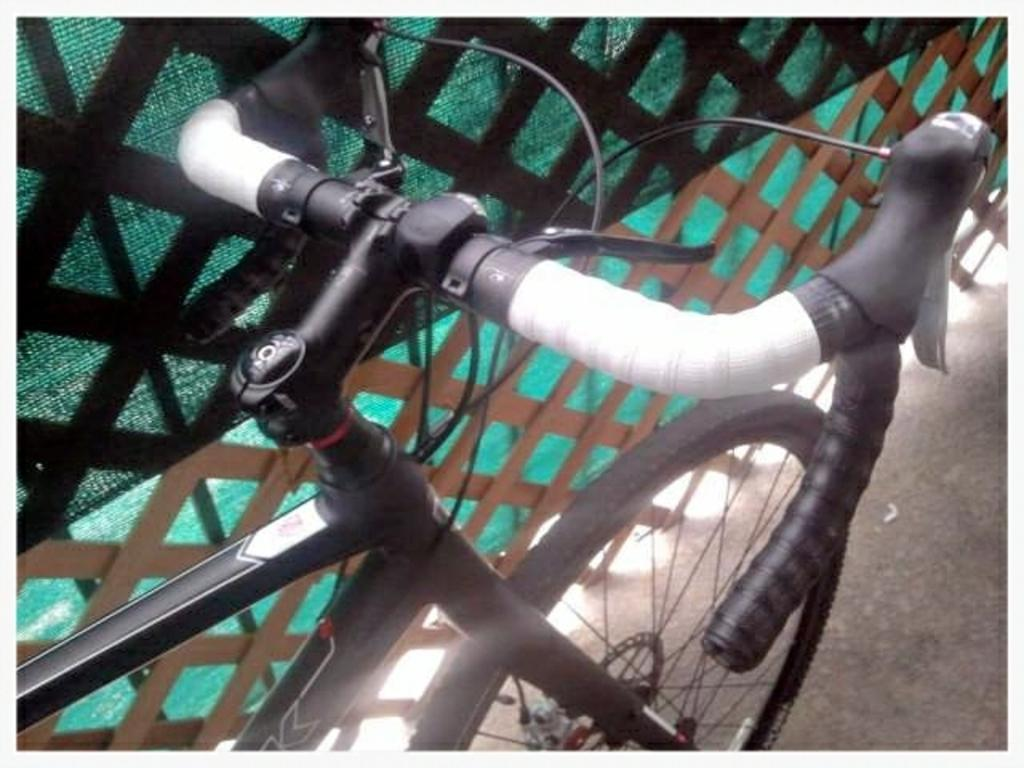What is the main object in the image? There is a cycle in the image. What can be seen near the cycle? There is a fencing with wooden sticks in the image. Is there any cloth associated with the fencing? Yes, there is a cloth associated with the fencing in the image. What type of vest is the zebra wearing in the image? There is no zebra or vest present in the image. 